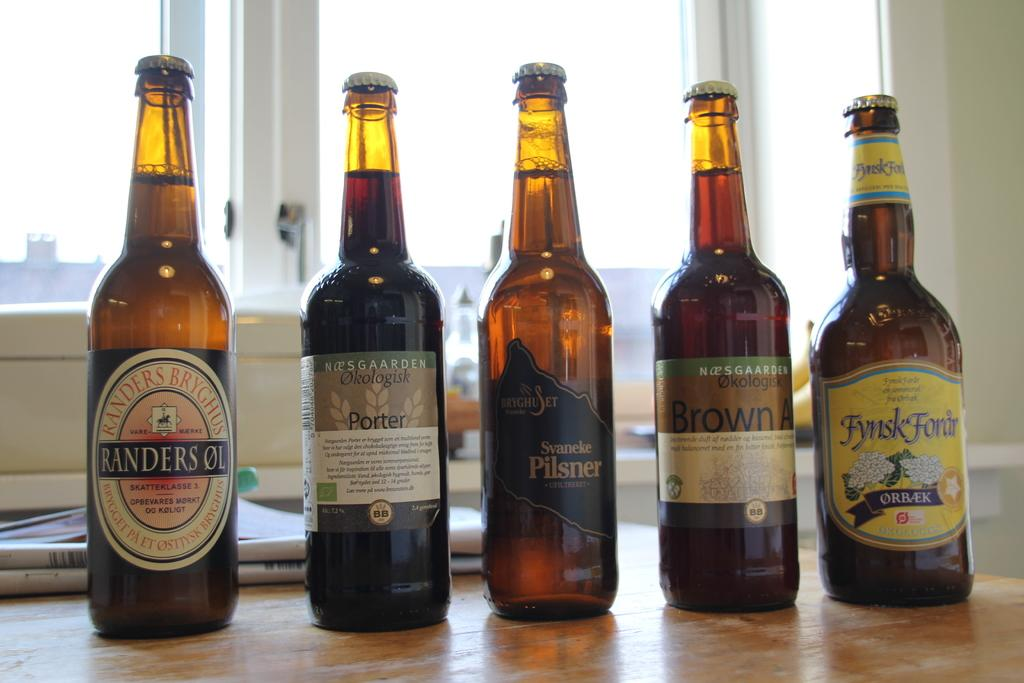Provide a one-sentence caption for the provided image. Five different bottles of beer are shown side-by-side on a table. 